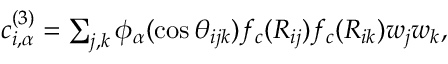<formula> <loc_0><loc_0><loc_500><loc_500>\begin{array} { r } { c _ { i , \alpha } ^ { ( 3 ) } = \sum _ { j , k } \phi _ { \alpha } ( \cos { \theta _ { i j k } } ) f _ { c } ( R _ { i j } ) f _ { c } ( R _ { i k } ) w _ { j } w _ { k } , } \end{array}</formula> 